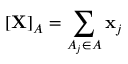<formula> <loc_0><loc_0><loc_500><loc_500>[ X ] _ { A } = \sum _ { A _ { j } \in A } x _ { j }</formula> 